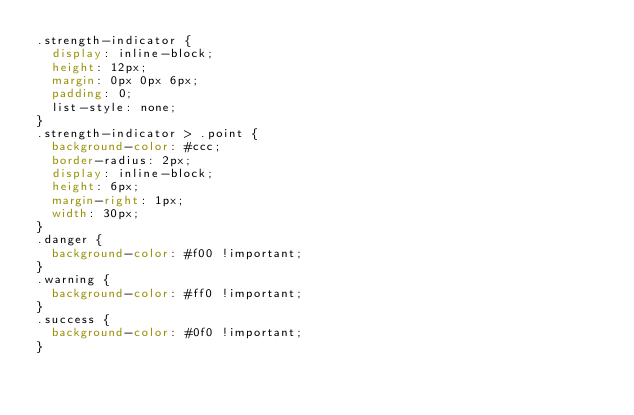Convert code to text. <code><loc_0><loc_0><loc_500><loc_500><_CSS_>.strength-indicator {
  display: inline-block;
  height: 12px;
  margin: 0px 0px 6px;
  padding: 0;
  list-style: none;
}
.strength-indicator > .point {
  background-color: #ccc;
  border-radius: 2px;
  display: inline-block;
  height: 6px;
  margin-right: 1px;
  width: 30px;
}
.danger {
  background-color: #f00 !important;
}
.warning {
  background-color: #ff0 !important;
}
.success {
  background-color: #0f0 !important;
}
</code> 